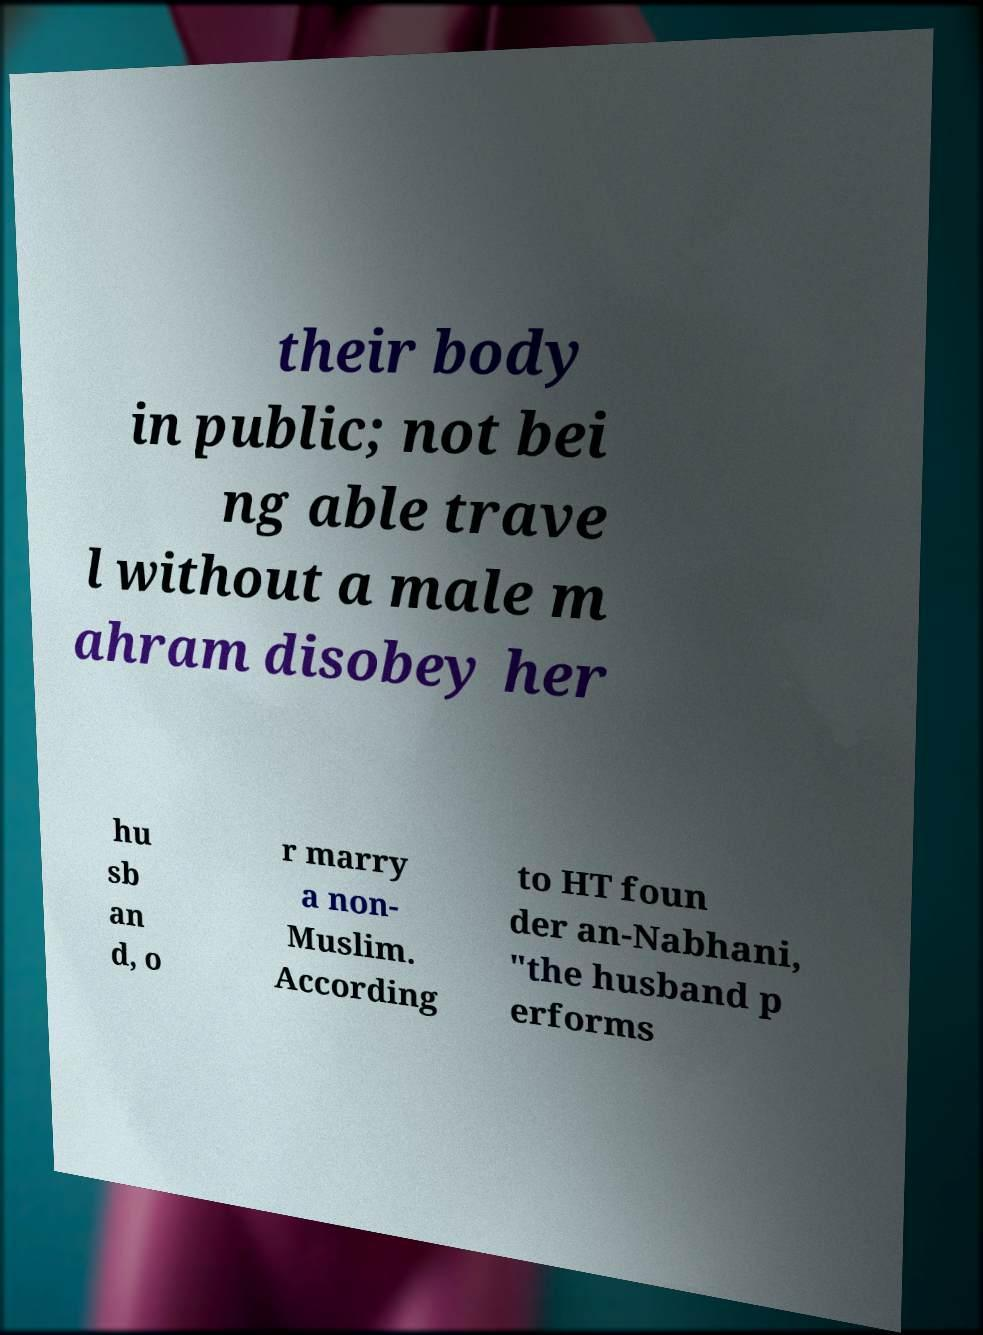Could you assist in decoding the text presented in this image and type it out clearly? their body in public; not bei ng able trave l without a male m ahram disobey her hu sb an d, o r marry a non- Muslim. According to HT foun der an-Nabhani, "the husband p erforms 